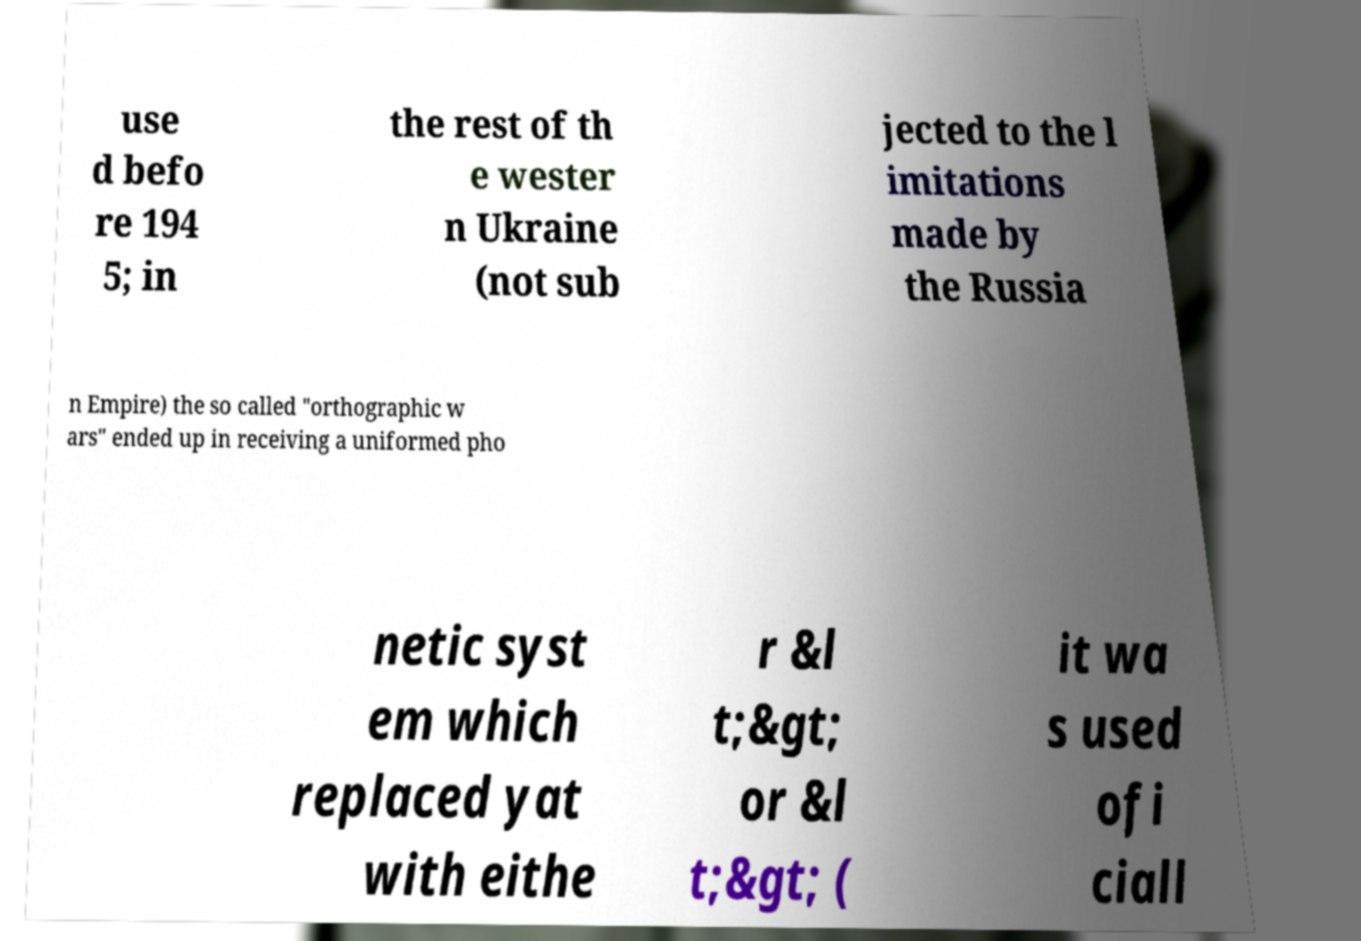Could you extract and type out the text from this image? use d befo re 194 5; in the rest of th e wester n Ukraine (not sub jected to the l imitations made by the Russia n Empire) the so called "orthographic w ars" ended up in receiving a uniformed pho netic syst em which replaced yat with eithe r &l t;&gt; or &l t;&gt; ( it wa s used ofi ciall 